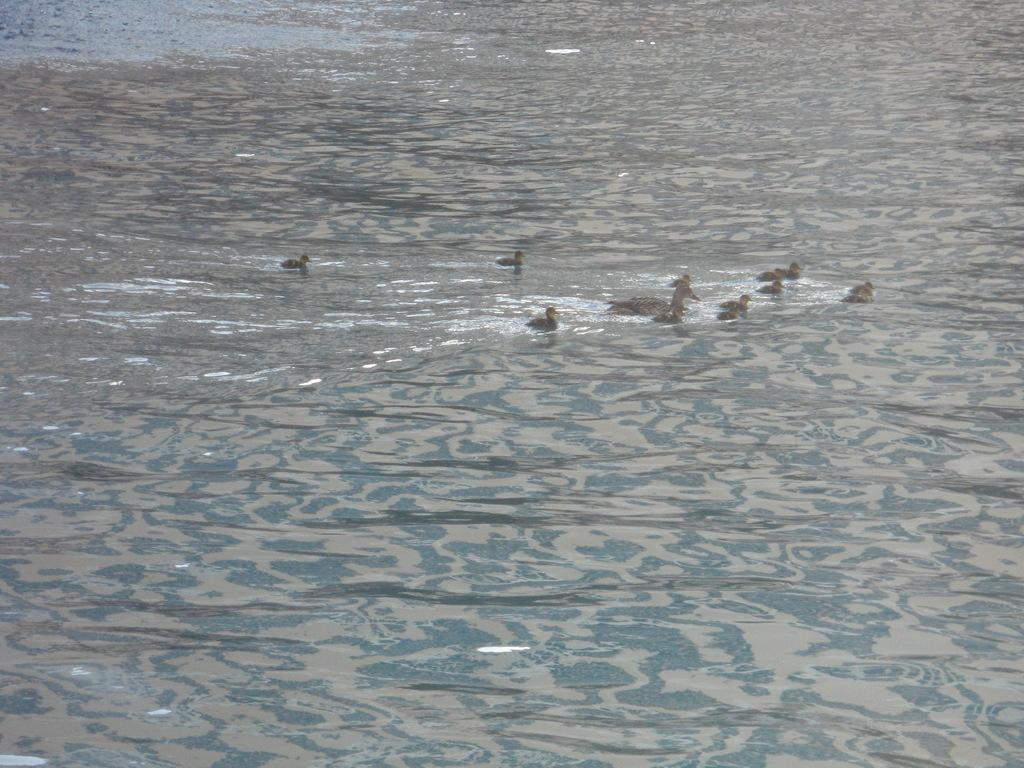What type of animals are in the image? There are ducks in the image. Where are the ducks located in the image? The ducks are in the water. What type of story is being told by the rabbits in the image? There are no rabbits present in the image, only ducks in the water. 